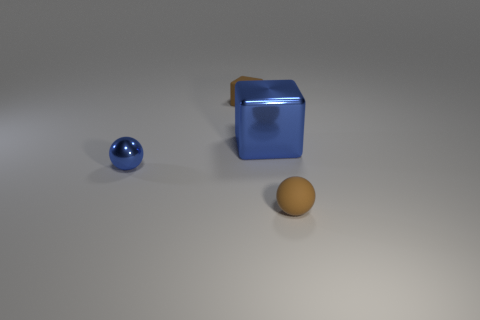The brown thing that is in front of the brown block has what shape?
Your response must be concise. Sphere. Is the number of blue metallic spheres that are right of the big object less than the number of big cubes to the left of the tiny metal ball?
Provide a short and direct response. No. Is the size of the rubber block the same as the sphere that is in front of the tiny blue metallic thing?
Provide a succinct answer. Yes. What number of green metal cylinders are the same size as the blue metallic sphere?
Make the answer very short. 0. What color is the thing that is the same material as the brown block?
Keep it short and to the point. Brown. Are there more tiny blue metallic spheres than tiny purple cylinders?
Provide a short and direct response. Yes. Is the material of the large cube the same as the brown ball?
Your answer should be very brief. No. The blue thing that is the same material as the big blue cube is what shape?
Provide a short and direct response. Sphere. Is the number of large blue metallic objects less than the number of rubber things?
Offer a very short reply. Yes. What is the tiny thing that is in front of the metal cube and left of the large blue metal block made of?
Ensure brevity in your answer.  Metal. 